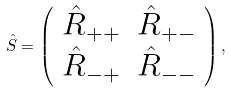Convert formula to latex. <formula><loc_0><loc_0><loc_500><loc_500>\hat { S } = \left ( \begin{array} { c c } \hat { R } _ { + + } & \hat { R } _ { + - } \\ \hat { R } _ { - + } & \hat { R } _ { - - } \\ \end{array} \right ) ,</formula> 